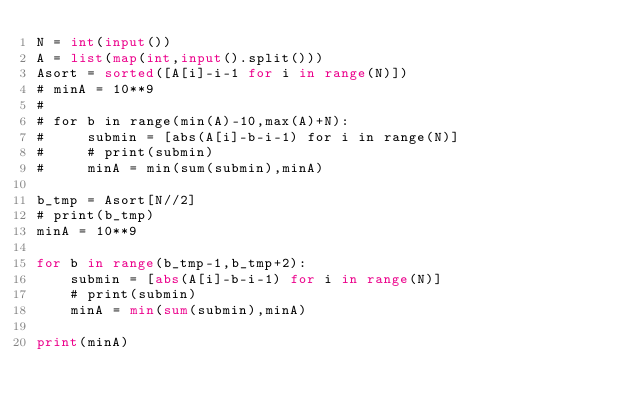<code> <loc_0><loc_0><loc_500><loc_500><_Python_>N = int(input())
A = list(map(int,input().split()))
Asort = sorted([A[i]-i-1 for i in range(N)])
# minA = 10**9
#
# for b in range(min(A)-10,max(A)+N):
#     submin = [abs(A[i]-b-i-1) for i in range(N)]
#     # print(submin)
#     minA = min(sum(submin),minA)

b_tmp = Asort[N//2]
# print(b_tmp)
minA = 10**9

for b in range(b_tmp-1,b_tmp+2):
    submin = [abs(A[i]-b-i-1) for i in range(N)]
    # print(submin)
    minA = min(sum(submin),minA)

print(minA)</code> 